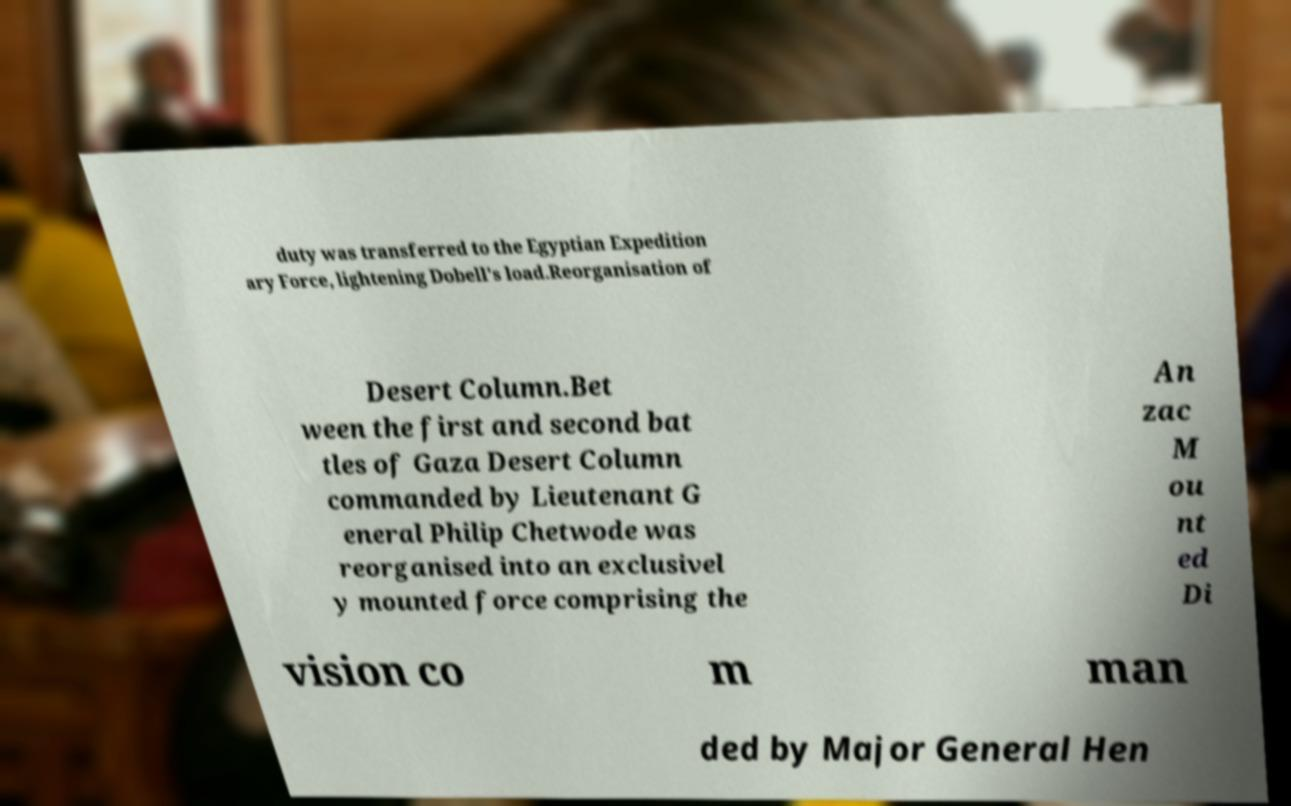There's text embedded in this image that I need extracted. Can you transcribe it verbatim? duty was transferred to the Egyptian Expedition ary Force, lightening Dobell's load.Reorganisation of Desert Column.Bet ween the first and second bat tles of Gaza Desert Column commanded by Lieutenant G eneral Philip Chetwode was reorganised into an exclusivel y mounted force comprising the An zac M ou nt ed Di vision co m man ded by Major General Hen 